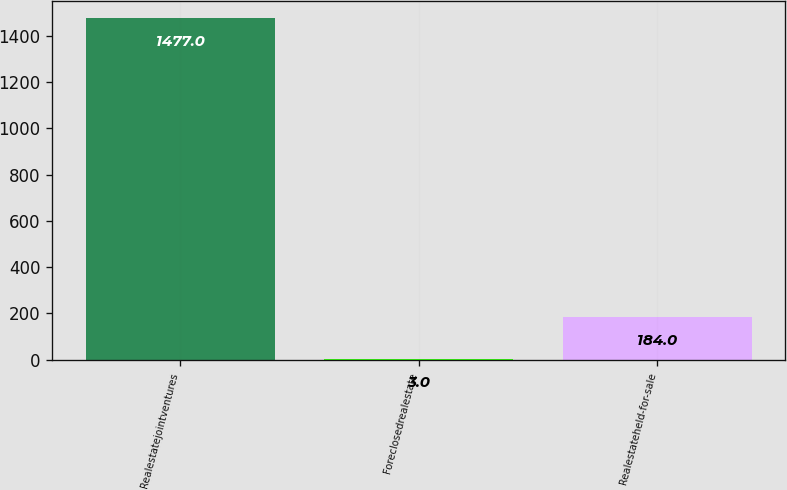<chart> <loc_0><loc_0><loc_500><loc_500><bar_chart><fcel>Realestatejointventures<fcel>Foreclosedrealestate<fcel>Realestateheld-for-sale<nl><fcel>1477<fcel>3<fcel>184<nl></chart> 